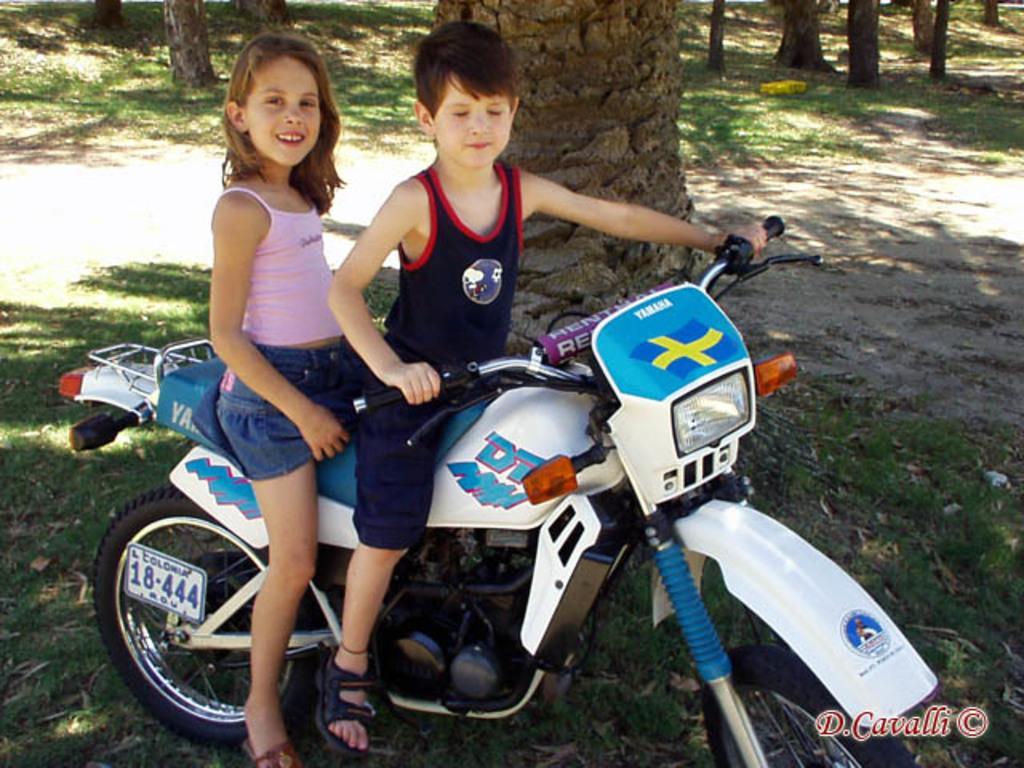How would you summarize this image in a sentence or two? In this image we can see two kids are seated on the bike, a girl is seated on the back side and she is smiling, in background we can see grass and couple of trees. 